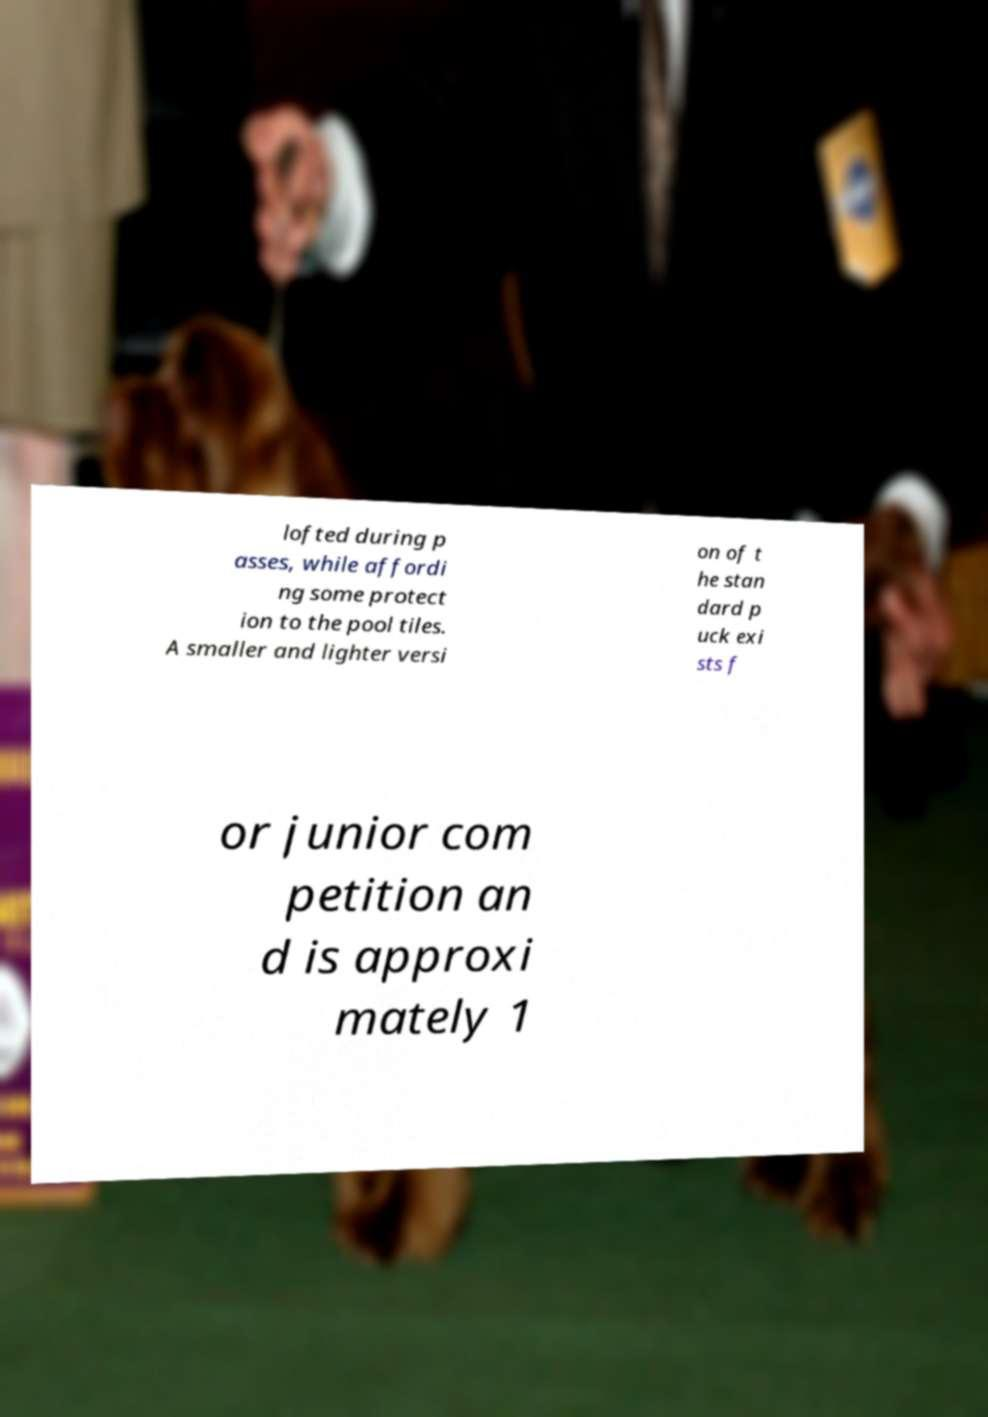Could you assist in decoding the text presented in this image and type it out clearly? lofted during p asses, while affordi ng some protect ion to the pool tiles. A smaller and lighter versi on of t he stan dard p uck exi sts f or junior com petition an d is approxi mately 1 